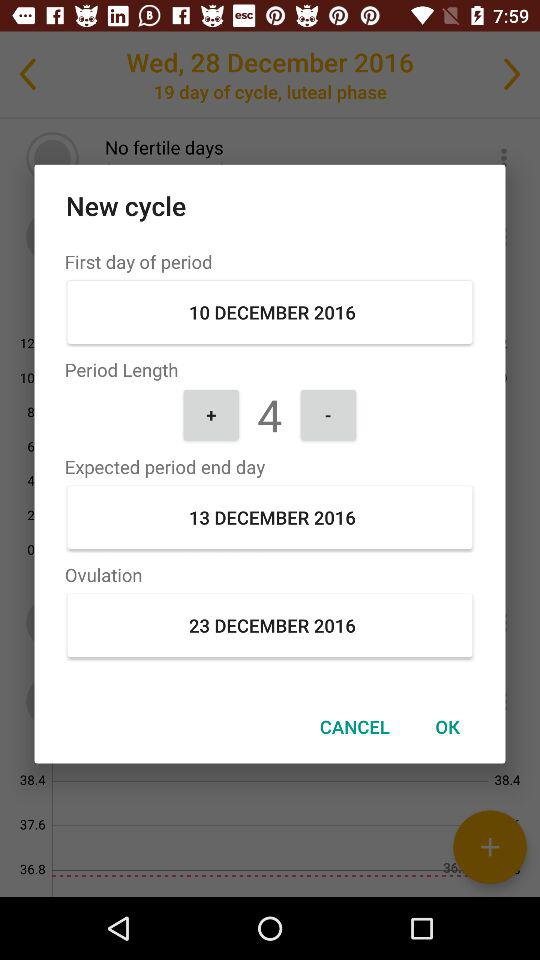What is the period length? The period length is 4. 